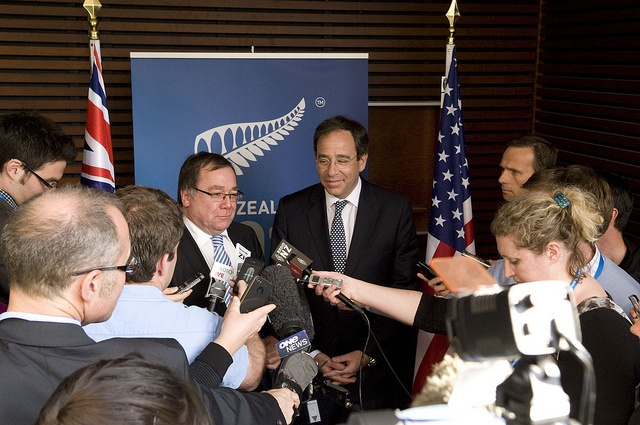Describe the objects in this image and their specific colors. I can see people in black, gray, and tan tones, people in black, gray, and brown tones, people in black, tan, and gray tones, people in black, lavender, gray, and maroon tones, and people in black, white, and salmon tones in this image. 